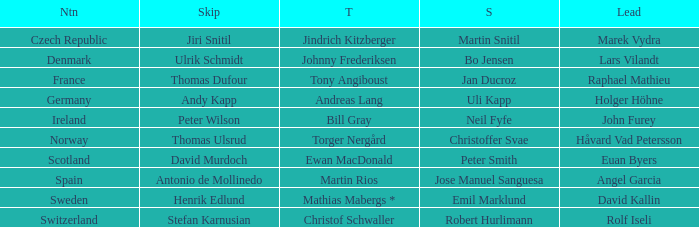Which skip consists of one-third of tony angiboust? Thomas Dufour. 